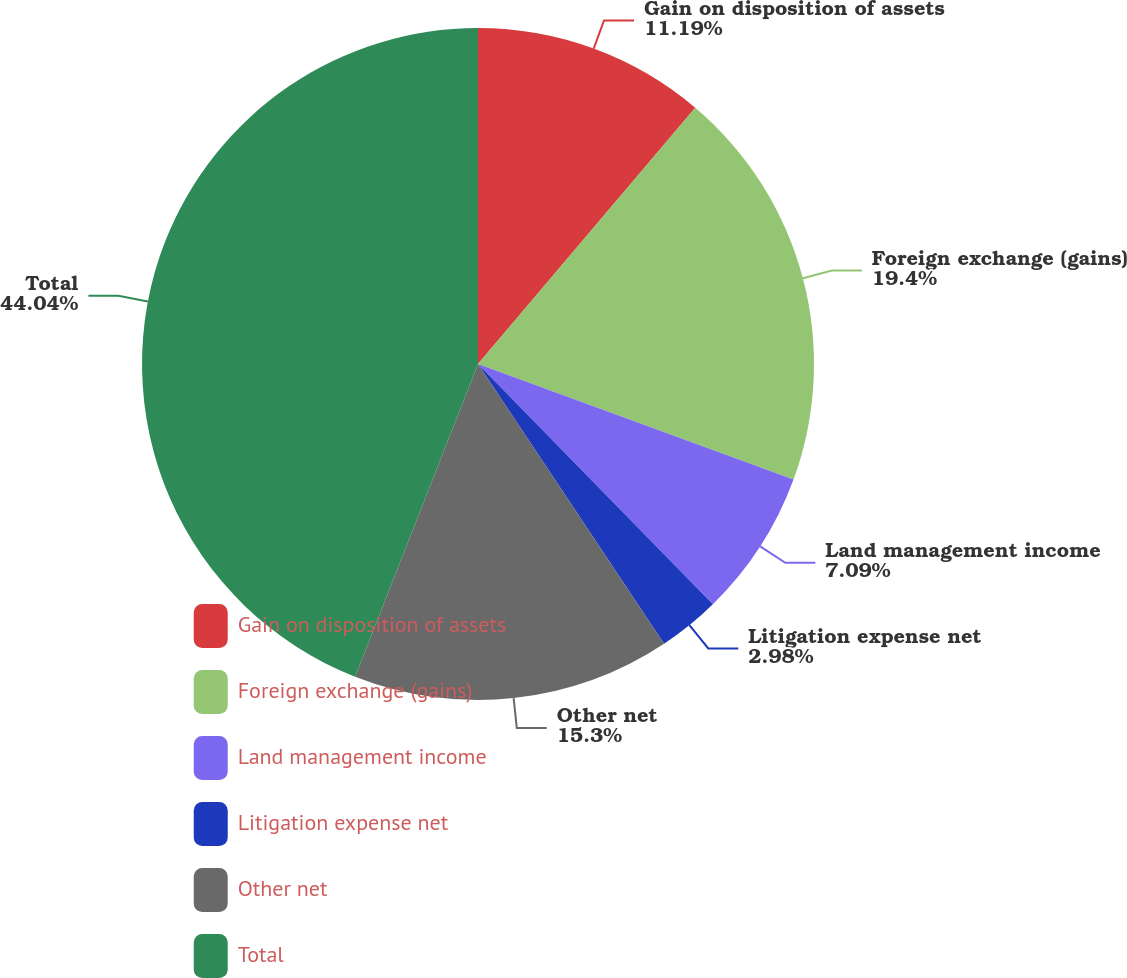<chart> <loc_0><loc_0><loc_500><loc_500><pie_chart><fcel>Gain on disposition of assets<fcel>Foreign exchange (gains)<fcel>Land management income<fcel>Litigation expense net<fcel>Other net<fcel>Total<nl><fcel>11.19%<fcel>19.4%<fcel>7.09%<fcel>2.98%<fcel>15.3%<fcel>44.04%<nl></chart> 